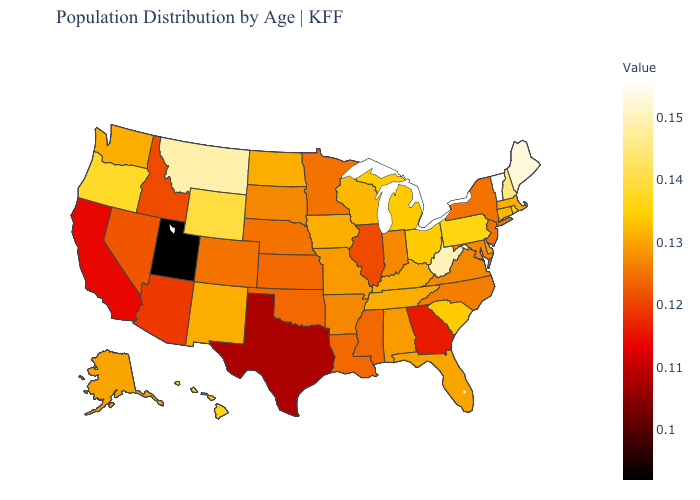Does Alaska have a higher value than Arizona?
Quick response, please. Yes. Does Delaware have the lowest value in the USA?
Concise answer only. No. Which states have the lowest value in the South?
Keep it brief. Texas. Does Utah have the lowest value in the USA?
Be succinct. Yes. Does Washington have a higher value than Illinois?
Keep it brief. Yes. Does Texas have the lowest value in the South?
Write a very short answer. Yes. Among the states that border Maryland , which have the lowest value?
Short answer required. Virginia. Which states have the highest value in the USA?
Be succinct. Vermont. 